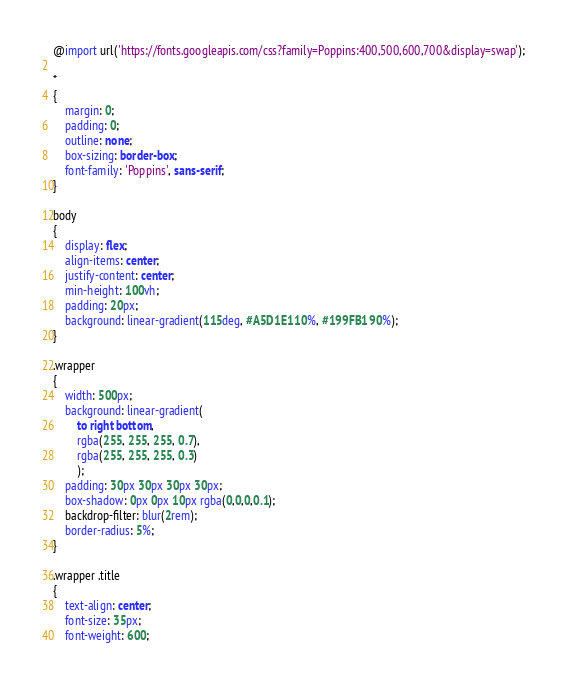<code> <loc_0><loc_0><loc_500><loc_500><_CSS_>@import url('https://fonts.googleapis.com/css?family=Poppins:400,500,600,700&display=swap');

*
{
    margin: 0;
    padding: 0;
    outline: none;
    box-sizing: border-box;
    font-family: 'Poppins', sans-serif;
}

body
{
    display: flex;
    align-items: center;
    justify-content: center;
    min-height: 100vh;
    padding: 20px;
    background: linear-gradient(115deg, #A5D1E1 10%, #199FB1 90%);
}

.wrapper
{
    width: 500px;
    background: linear-gradient(
        to right bottom,
        rgba(255, 255, 255, 0.7),
        rgba(255, 255, 255, 0.3)
        );
    padding: 30px 30px 30px 30px;
    box-shadow: 0px 0px 10px rgba(0,0,0,0.1);
    backdrop-filter: blur(2rem);
    border-radius: 5%;
}

.wrapper .title
{
    text-align: center;
    font-size: 35px;
    font-weight: 600;</code> 